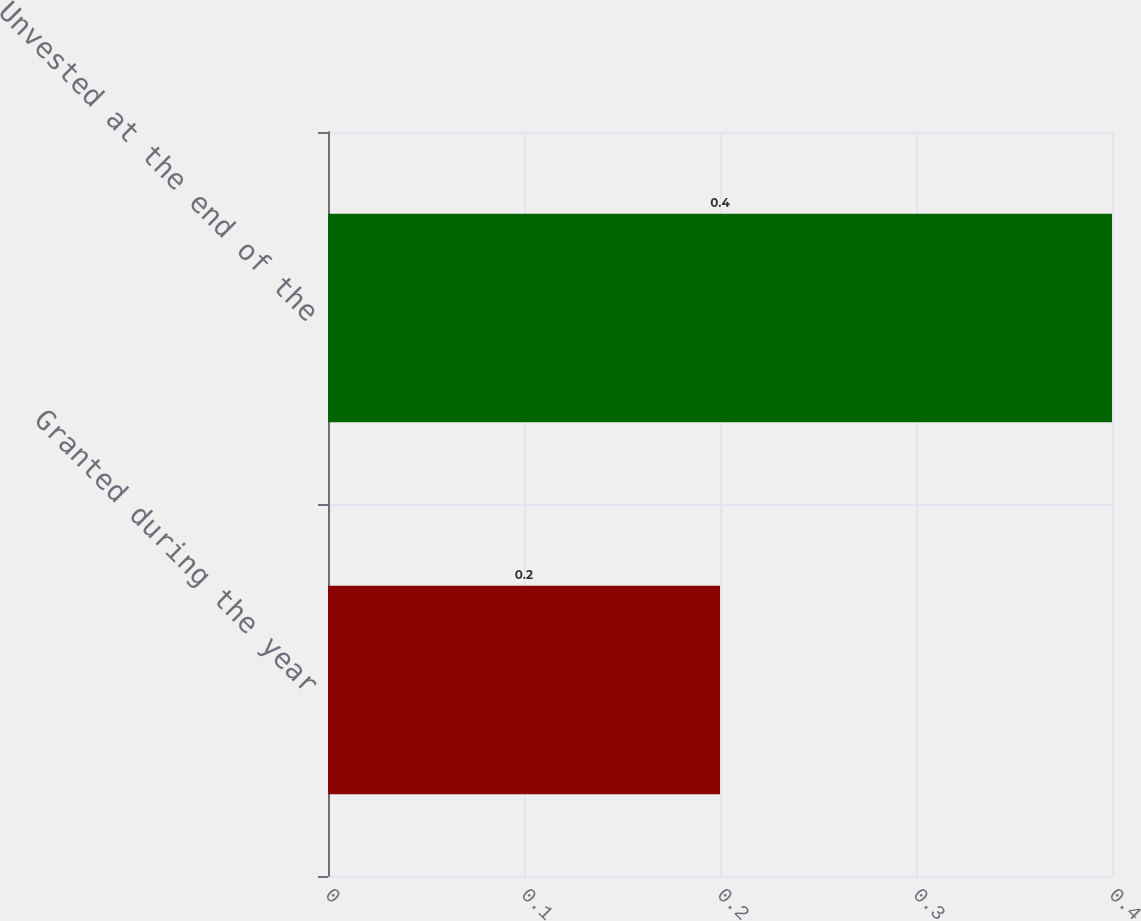Convert chart. <chart><loc_0><loc_0><loc_500><loc_500><bar_chart><fcel>Granted during the year<fcel>Unvested at the end of the<nl><fcel>0.2<fcel>0.4<nl></chart> 